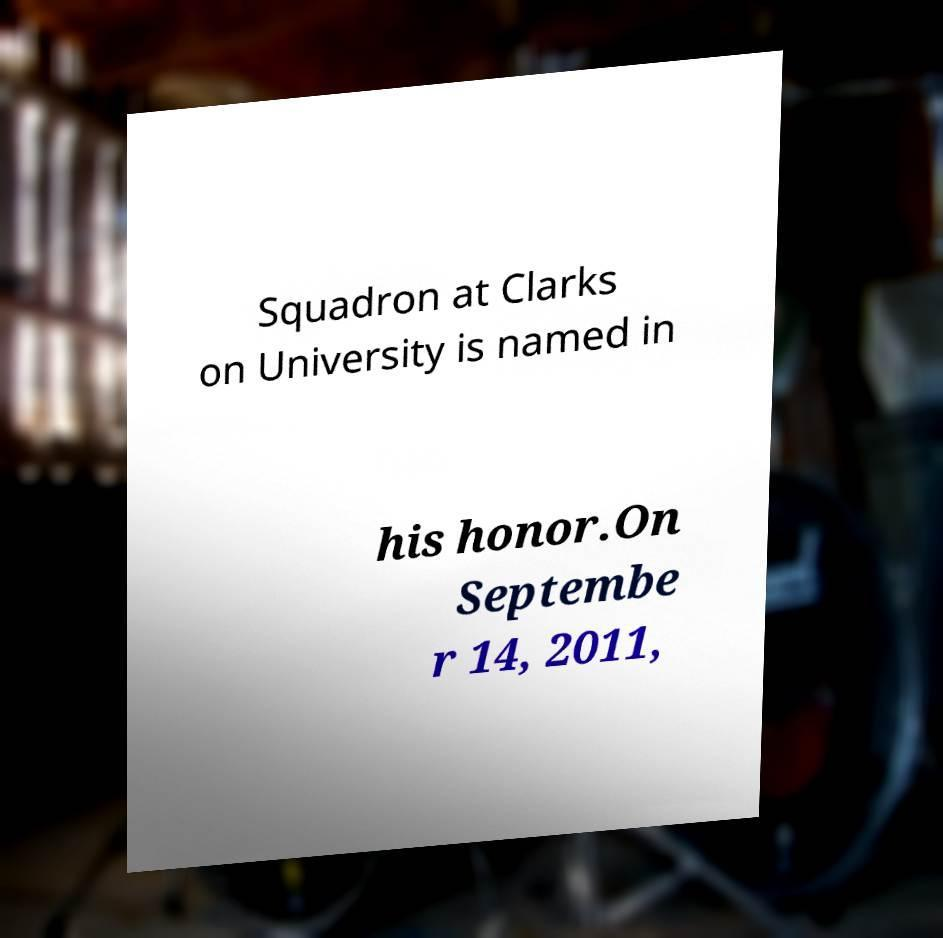Can you accurately transcribe the text from the provided image for me? Squadron at Clarks on University is named in his honor.On Septembe r 14, 2011, 